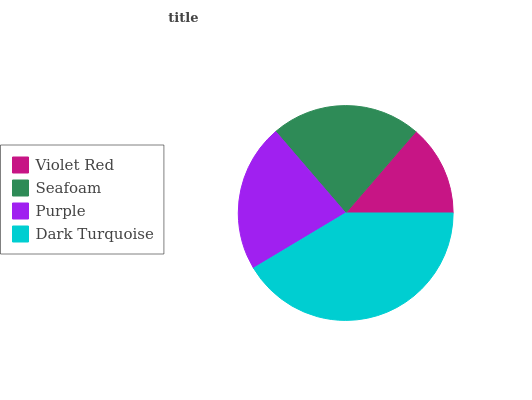Is Violet Red the minimum?
Answer yes or no. Yes. Is Dark Turquoise the maximum?
Answer yes or no. Yes. Is Seafoam the minimum?
Answer yes or no. No. Is Seafoam the maximum?
Answer yes or no. No. Is Seafoam greater than Violet Red?
Answer yes or no. Yes. Is Violet Red less than Seafoam?
Answer yes or no. Yes. Is Violet Red greater than Seafoam?
Answer yes or no. No. Is Seafoam less than Violet Red?
Answer yes or no. No. Is Seafoam the high median?
Answer yes or no. Yes. Is Purple the low median?
Answer yes or no. Yes. Is Dark Turquoise the high median?
Answer yes or no. No. Is Dark Turquoise the low median?
Answer yes or no. No. 